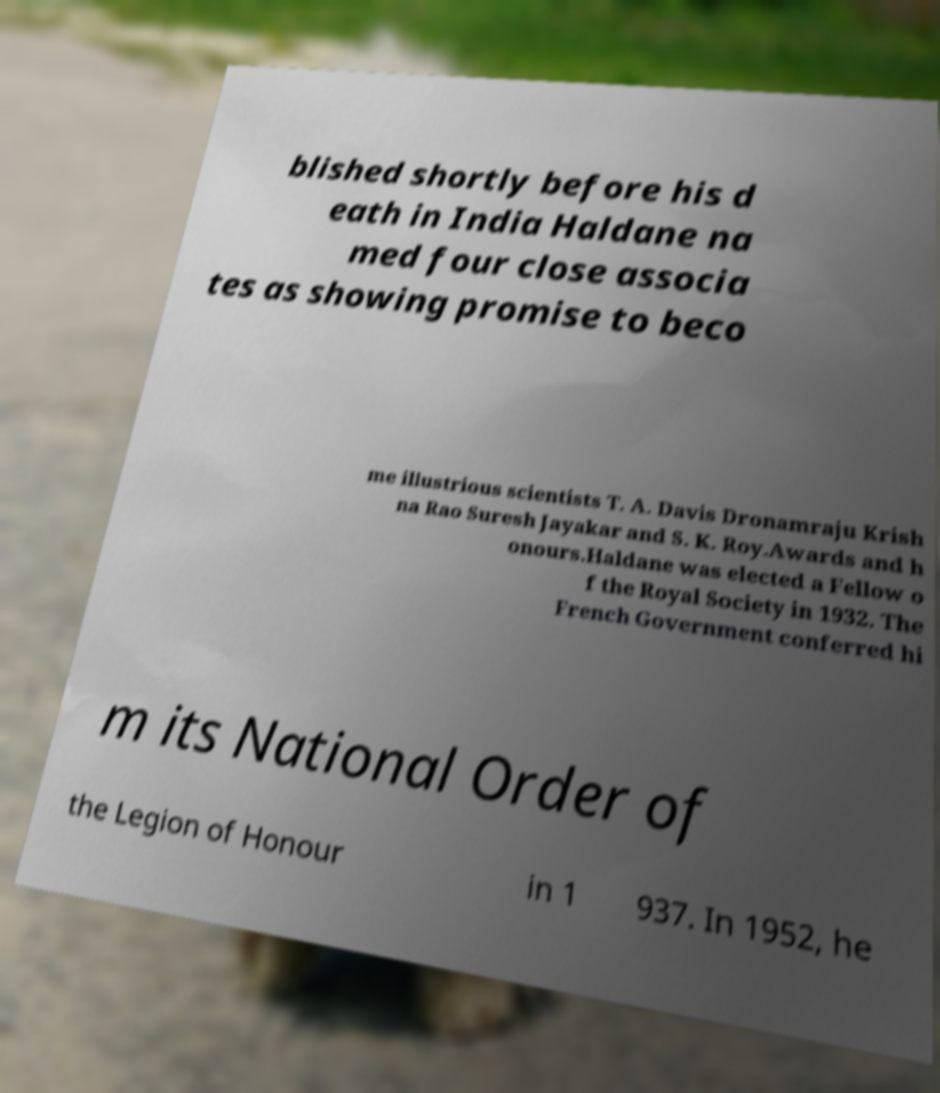For documentation purposes, I need the text within this image transcribed. Could you provide that? blished shortly before his d eath in India Haldane na med four close associa tes as showing promise to beco me illustrious scientists T. A. Davis Dronamraju Krish na Rao Suresh Jayakar and S. K. Roy.Awards and h onours.Haldane was elected a Fellow o f the Royal Society in 1932. The French Government conferred hi m its National Order of the Legion of Honour in 1 937. In 1952, he 